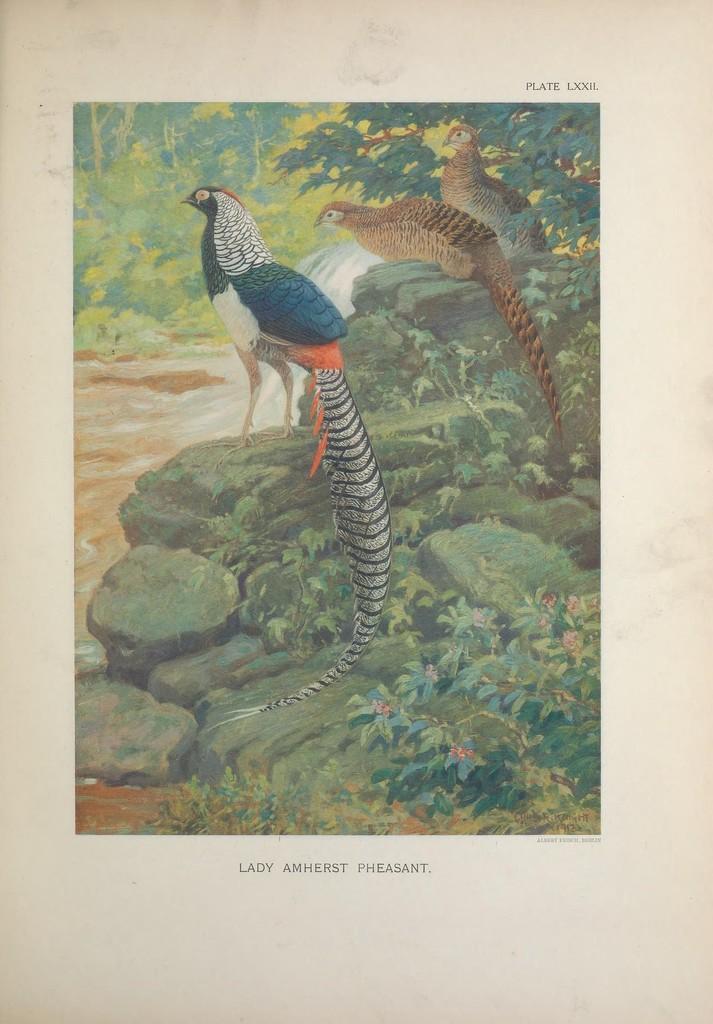Could you give a brief overview of what you see in this image? This is a poster and in the foreground of this poster, there are few peacocks standing on the side rocks of the river. In the background, there are trees. 